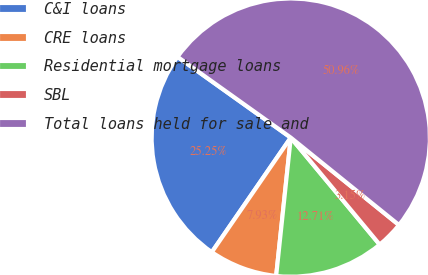Convert chart. <chart><loc_0><loc_0><loc_500><loc_500><pie_chart><fcel>C&I loans<fcel>CRE loans<fcel>Residential mortgage loans<fcel>SBL<fcel>Total loans held for sale and<nl><fcel>25.25%<fcel>7.93%<fcel>12.71%<fcel>3.15%<fcel>50.95%<nl></chart> 